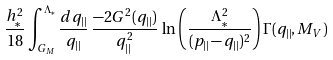Convert formula to latex. <formula><loc_0><loc_0><loc_500><loc_500>\frac { h _ { \ast } ^ { 2 } } { 1 8 } \int _ { G _ { M } } ^ { \Lambda _ { \ast } } \frac { d q _ { | | } } { q _ { | | } } \, \frac { - 2 G ^ { 2 } ( q _ { | | } ) } { q _ { | | } ^ { 2 } } \, \ln \left ( \frac { \Lambda _ { \ast } ^ { 2 } } { ( p _ { | | } - q _ { | | } ) ^ { 2 } } \right ) \Gamma ( q _ { | | } , M _ { V } ) \,</formula> 